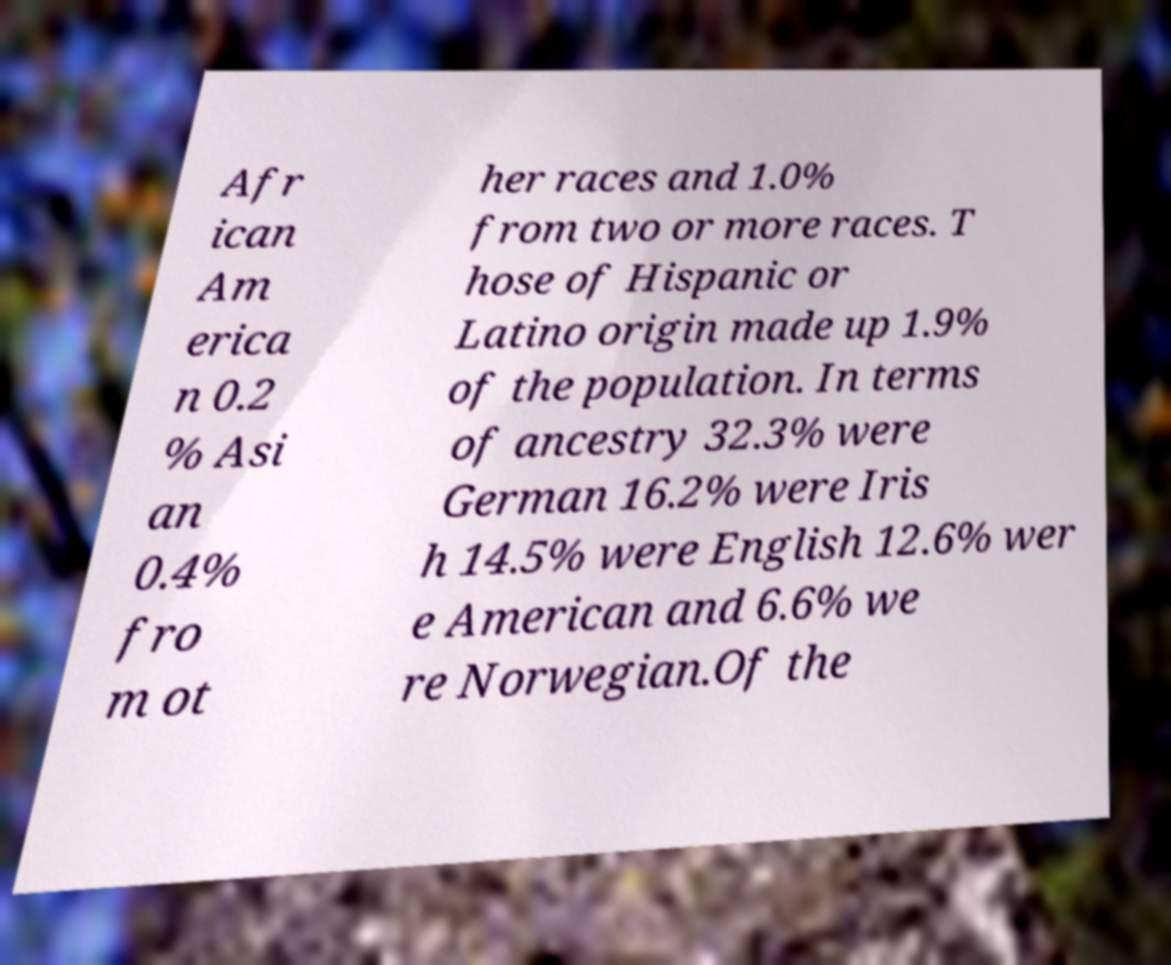For documentation purposes, I need the text within this image transcribed. Could you provide that? Afr ican Am erica n 0.2 % Asi an 0.4% fro m ot her races and 1.0% from two or more races. T hose of Hispanic or Latino origin made up 1.9% of the population. In terms of ancestry 32.3% were German 16.2% were Iris h 14.5% were English 12.6% wer e American and 6.6% we re Norwegian.Of the 